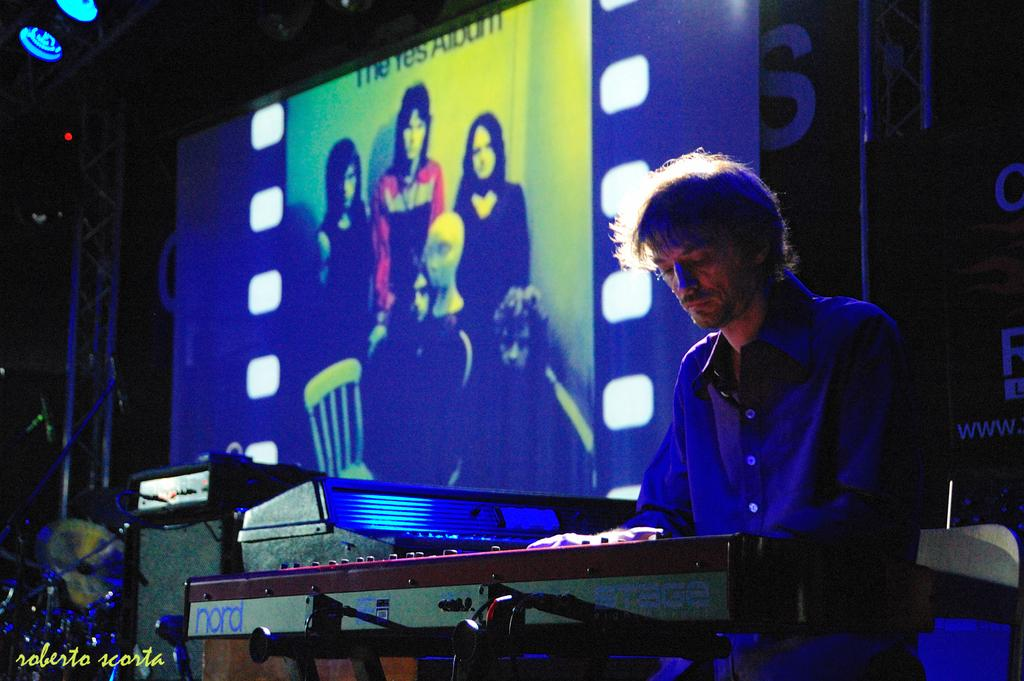What is the person in the image doing? The person is playing a musical instrument in the image. What can be seen in the background of the image? There is a screen, a metal rod, and a roof top in the background of the image. What time of day was the image taken? The image was taken during night time. What type of reaction can be seen from the turkey in the image? There is no turkey present in the image, so it is not possible to observe any reactions from a turkey. 